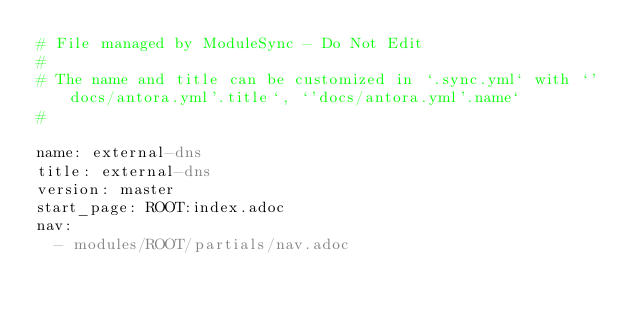<code> <loc_0><loc_0><loc_500><loc_500><_YAML_># File managed by ModuleSync - Do Not Edit
#
# The name and title can be customized in `.sync.yml` with `'docs/antora.yml'.title`, `'docs/antora.yml'.name`
#

name: external-dns
title: external-dns
version: master
start_page: ROOT:index.adoc
nav:
  - modules/ROOT/partials/nav.adoc
</code> 